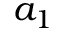Convert formula to latex. <formula><loc_0><loc_0><loc_500><loc_500>a _ { 1 }</formula> 